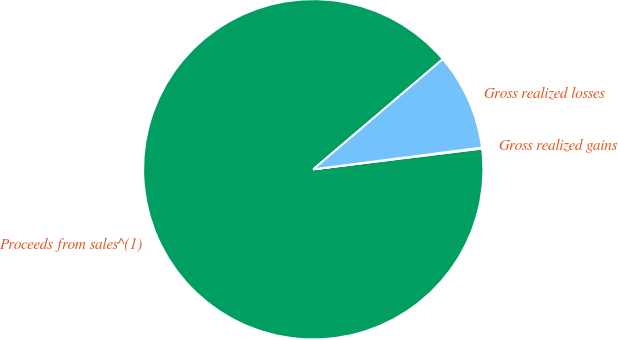Convert chart. <chart><loc_0><loc_0><loc_500><loc_500><pie_chart><fcel>Proceeds from sales^(1)<fcel>Gross realized gains<fcel>Gross realized losses<nl><fcel>90.73%<fcel>0.1%<fcel>9.17%<nl></chart> 